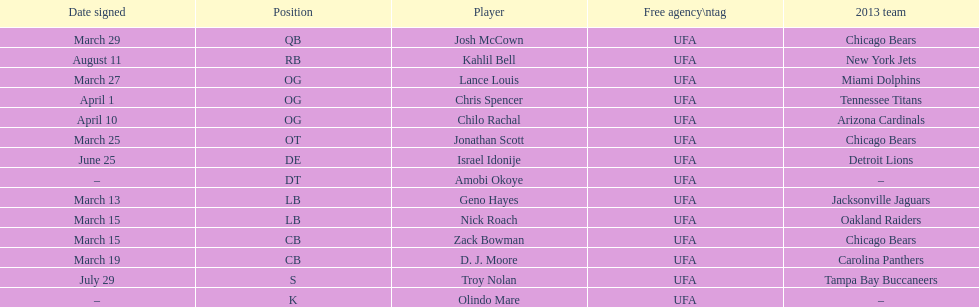I'm looking to parse the entire table for insights. Could you assist me with that? {'header': ['Date signed', 'Position', 'Player', 'Free agency\\ntag', '2013 team'], 'rows': [['March 29', 'QB', 'Josh McCown', 'UFA', 'Chicago Bears'], ['August 11', 'RB', 'Kahlil Bell', 'UFA', 'New York Jets'], ['March 27', 'OG', 'Lance Louis', 'UFA', 'Miami Dolphins'], ['April 1', 'OG', 'Chris Spencer', 'UFA', 'Tennessee Titans'], ['April 10', 'OG', 'Chilo Rachal', 'UFA', 'Arizona Cardinals'], ['March 25', 'OT', 'Jonathan Scott', 'UFA', 'Chicago Bears'], ['June 25', 'DE', 'Israel Idonije', 'UFA', 'Detroit Lions'], ['–', 'DT', 'Amobi Okoye', 'UFA', '–'], ['March 13', 'LB', 'Geno Hayes', 'UFA', 'Jacksonville Jaguars'], ['March 15', 'LB', 'Nick Roach', 'UFA', 'Oakland Raiders'], ['March 15', 'CB', 'Zack Bowman', 'UFA', 'Chicago Bears'], ['March 19', 'CB', 'D. J. Moore', 'UFA', 'Carolina Panthers'], ['July 29', 'S', 'Troy Nolan', 'UFA', 'Tampa Bay Buccaneers'], ['–', 'K', 'Olindo Mare', 'UFA', '–']]} The only player to sign in july? Troy Nolan. 